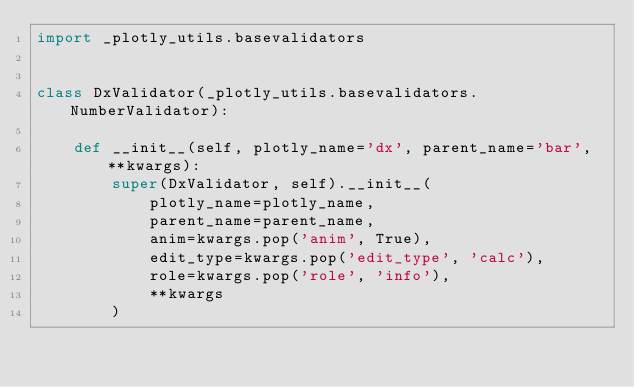Convert code to text. <code><loc_0><loc_0><loc_500><loc_500><_Python_>import _plotly_utils.basevalidators


class DxValidator(_plotly_utils.basevalidators.NumberValidator):

    def __init__(self, plotly_name='dx', parent_name='bar', **kwargs):
        super(DxValidator, self).__init__(
            plotly_name=plotly_name,
            parent_name=parent_name,
            anim=kwargs.pop('anim', True),
            edit_type=kwargs.pop('edit_type', 'calc'),
            role=kwargs.pop('role', 'info'),
            **kwargs
        )
</code> 